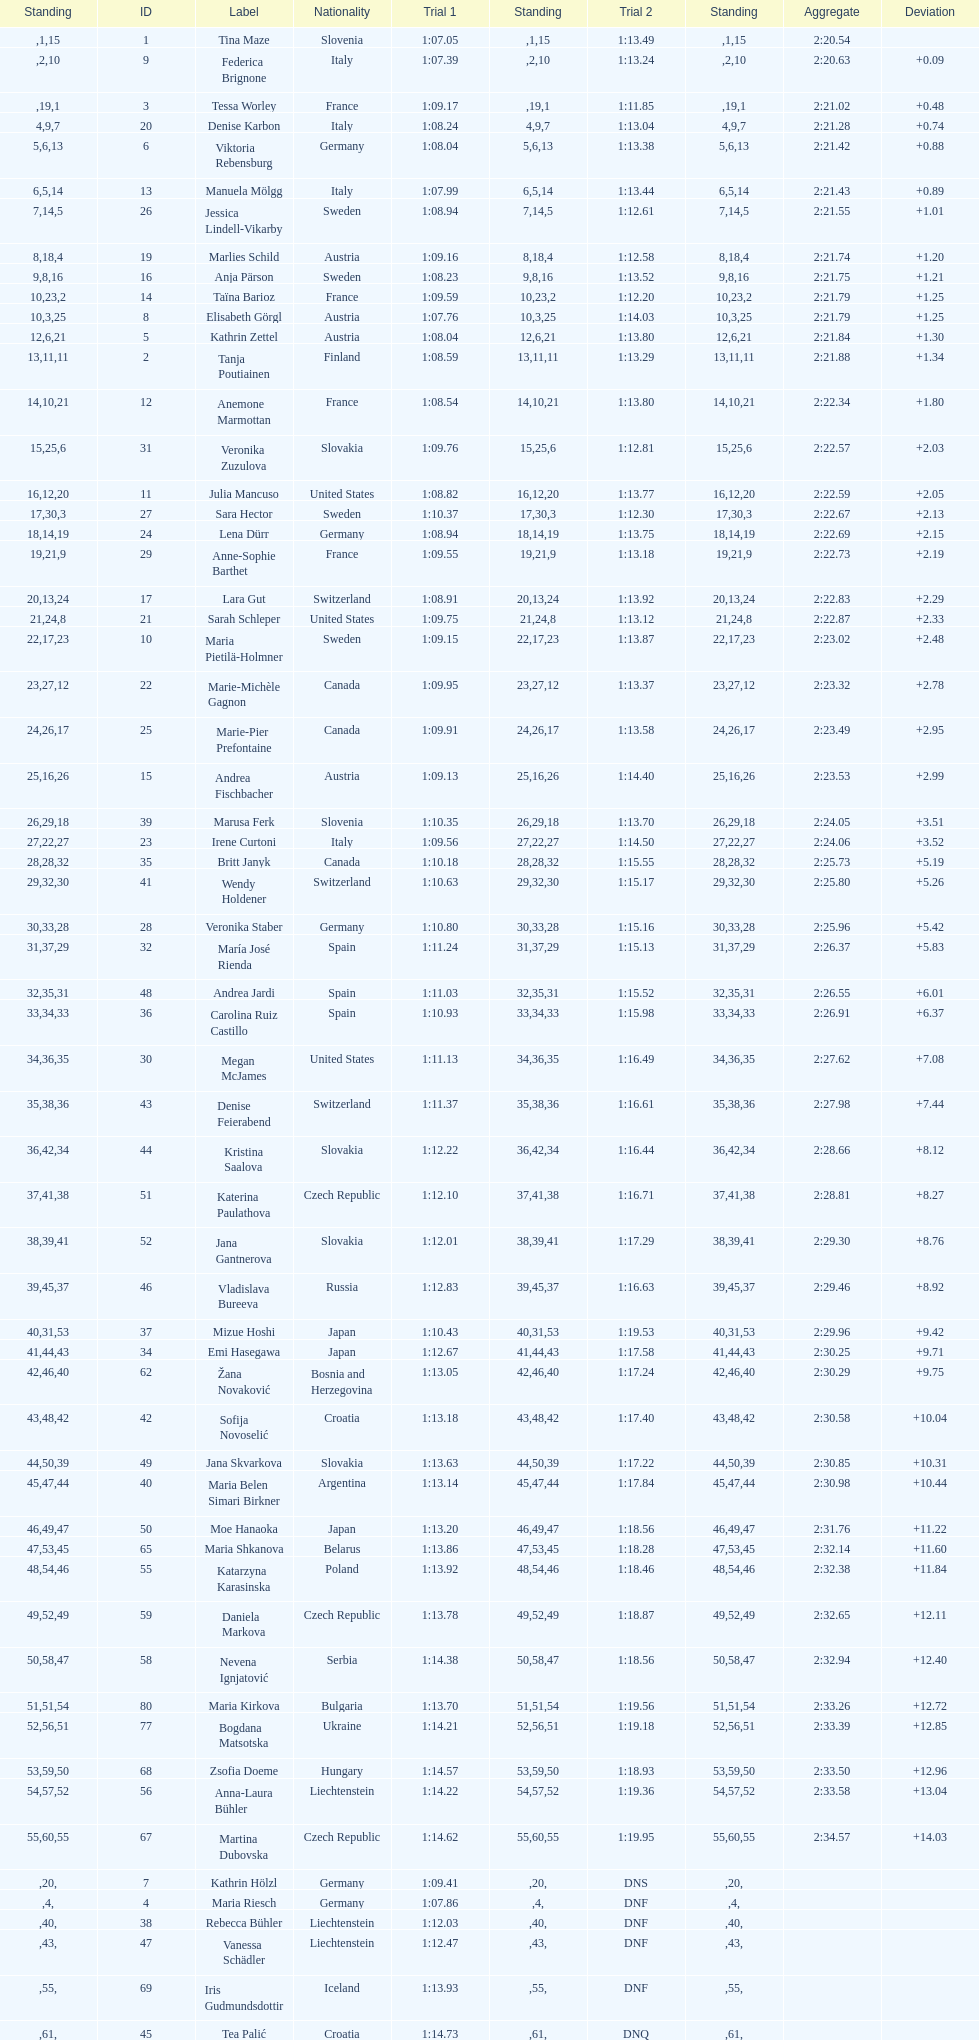What was the number of swedes in the top fifteen? 2. 